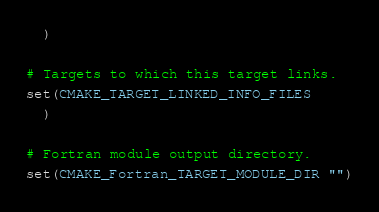Convert code to text. <code><loc_0><loc_0><loc_500><loc_500><_CMake_>  )

# Targets to which this target links.
set(CMAKE_TARGET_LINKED_INFO_FILES
  )

# Fortran module output directory.
set(CMAKE_Fortran_TARGET_MODULE_DIR "")
</code> 